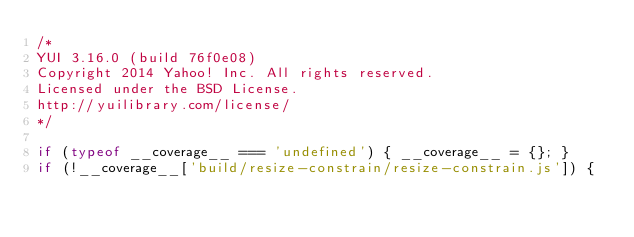<code> <loc_0><loc_0><loc_500><loc_500><_JavaScript_>/*
YUI 3.16.0 (build 76f0e08)
Copyright 2014 Yahoo! Inc. All rights reserved.
Licensed under the BSD License.
http://yuilibrary.com/license/
*/

if (typeof __coverage__ === 'undefined') { __coverage__ = {}; }
if (!__coverage__['build/resize-constrain/resize-constrain.js']) {</code> 